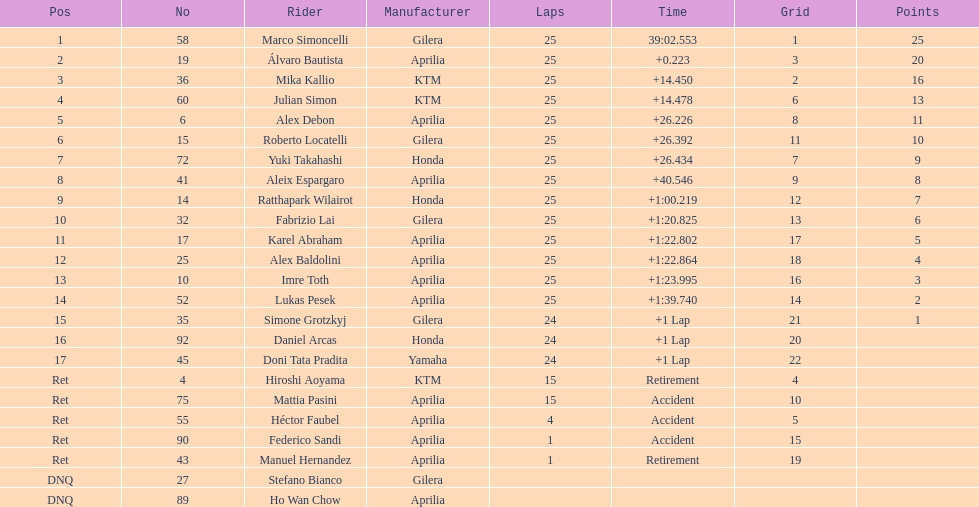Who is marco simoncelli's maker? Gilera. 